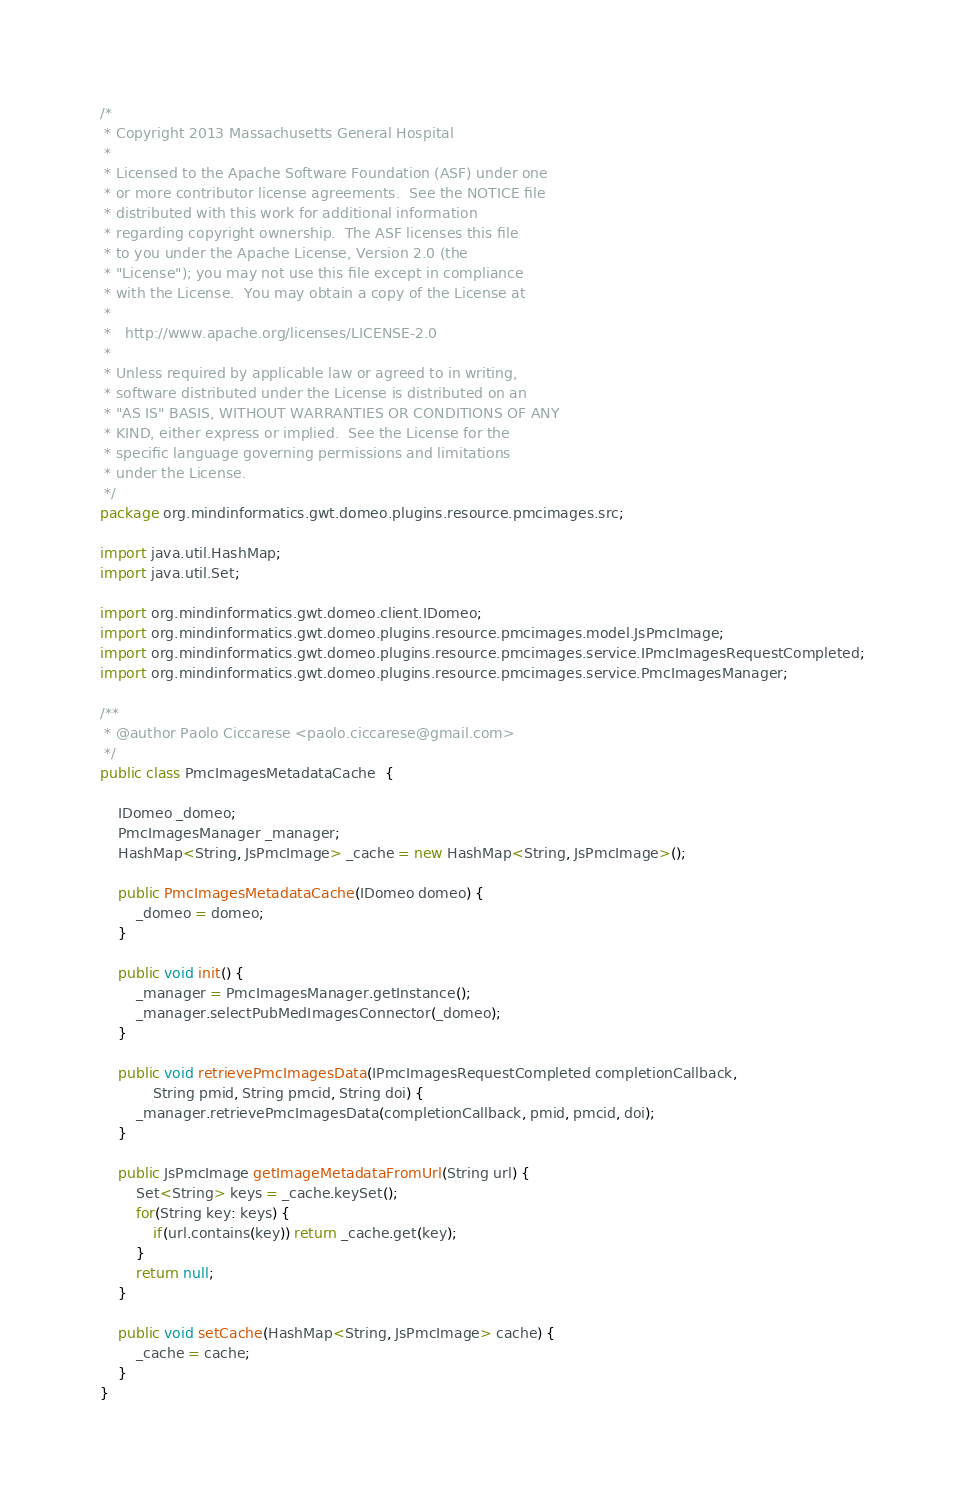<code> <loc_0><loc_0><loc_500><loc_500><_Java_>/*
 * Copyright 2013 Massachusetts General Hospital
 * 
 * Licensed to the Apache Software Foundation (ASF) under one
 * or more contributor license agreements.  See the NOTICE file
 * distributed with this work for additional information
 * regarding copyright ownership.  The ASF licenses this file
 * to you under the Apache License, Version 2.0 (the
 * "License"); you may not use this file except in compliance
 * with the License.  You may obtain a copy of the License at
 *
 *   http://www.apache.org/licenses/LICENSE-2.0
 *
 * Unless required by applicable law or agreed to in writing,
 * software distributed under the License is distributed on an
 * "AS IS" BASIS, WITHOUT WARRANTIES OR CONDITIONS OF ANY
 * KIND, either express or implied.  See the License for the
 * specific language governing permissions and limitations
 * under the License.
 */
package org.mindinformatics.gwt.domeo.plugins.resource.pmcimages.src;

import java.util.HashMap;
import java.util.Set;

import org.mindinformatics.gwt.domeo.client.IDomeo;
import org.mindinformatics.gwt.domeo.plugins.resource.pmcimages.model.JsPmcImage;
import org.mindinformatics.gwt.domeo.plugins.resource.pmcimages.service.IPmcImagesRequestCompleted;
import org.mindinformatics.gwt.domeo.plugins.resource.pmcimages.service.PmcImagesManager;

/**
 * @author Paolo Ciccarese <paolo.ciccarese@gmail.com>
 */
public class PmcImagesMetadataCache  {
	
	IDomeo _domeo;
	PmcImagesManager _manager;
	HashMap<String, JsPmcImage> _cache = new HashMap<String, JsPmcImage>();
	
	public PmcImagesMetadataCache(IDomeo domeo) {
		_domeo = domeo;
	}
	
	public void init() {
		_manager = PmcImagesManager.getInstance();
		_manager.selectPubMedImagesConnector(_domeo);
	}
	
	public void retrievePmcImagesData(IPmcImagesRequestCompleted completionCallback,
			String pmid, String pmcid, String doi) {
		_manager.retrievePmcImagesData(completionCallback, pmid, pmcid, doi);
	}
	
	public JsPmcImage getImageMetadataFromUrl(String url) {
		Set<String> keys = _cache.keySet();
		for(String key: keys) {
			if(url.contains(key)) return _cache.get(key);
		}
		return null;
	}
	
	public void setCache(HashMap<String, JsPmcImage> cache) {
		_cache = cache;
	}
}
</code> 